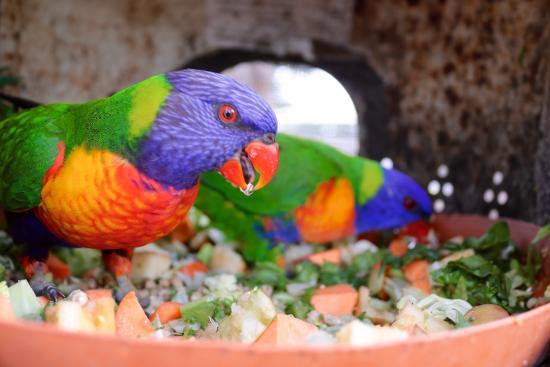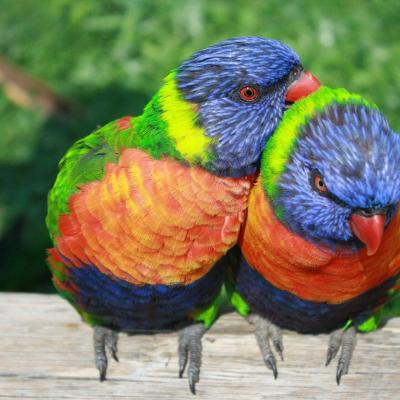The first image is the image on the left, the second image is the image on the right. Considering the images on both sides, is "An image shows a parrot perched among branches of red flowers with tendril petals." valid? Answer yes or no. No. The first image is the image on the left, the second image is the image on the right. Evaluate the accuracy of this statement regarding the images: "In one of the images there is a bird in a tree with red flowers.". Is it true? Answer yes or no. No. 